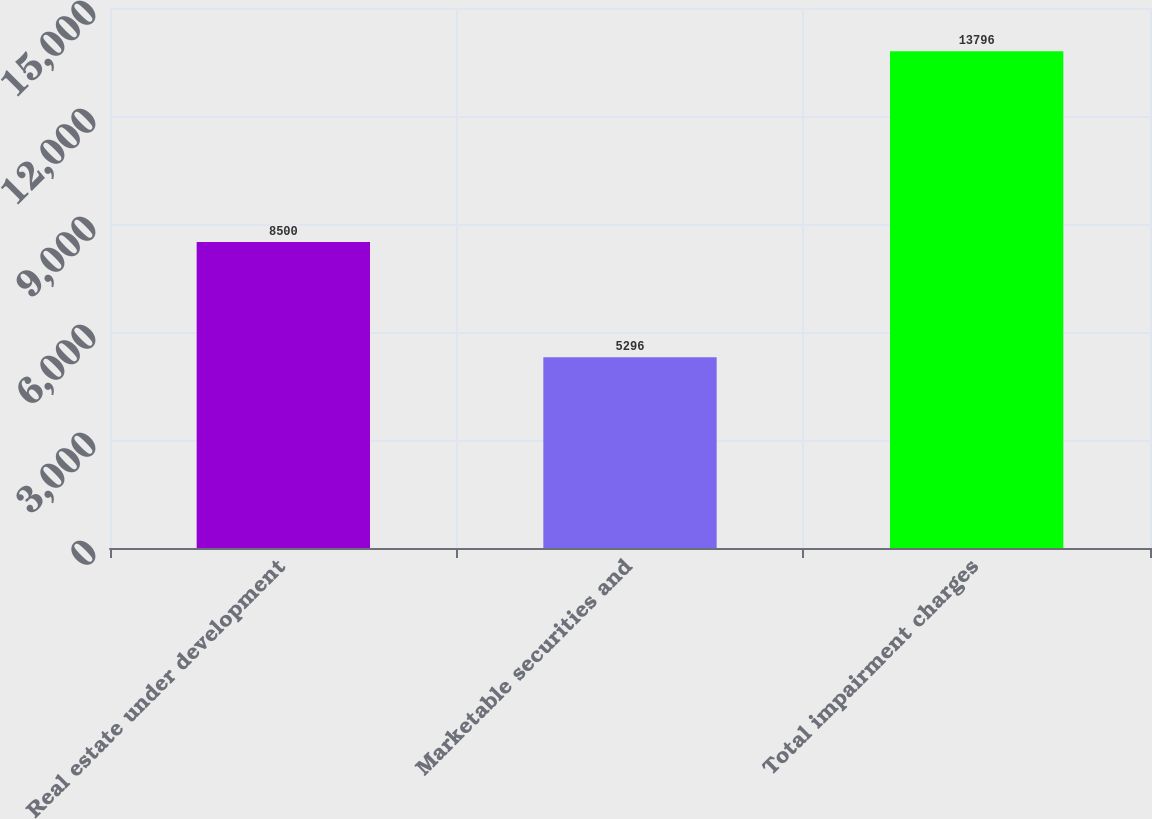<chart> <loc_0><loc_0><loc_500><loc_500><bar_chart><fcel>Real estate under development<fcel>Marketable securities and<fcel>Total impairment charges<nl><fcel>8500<fcel>5296<fcel>13796<nl></chart> 